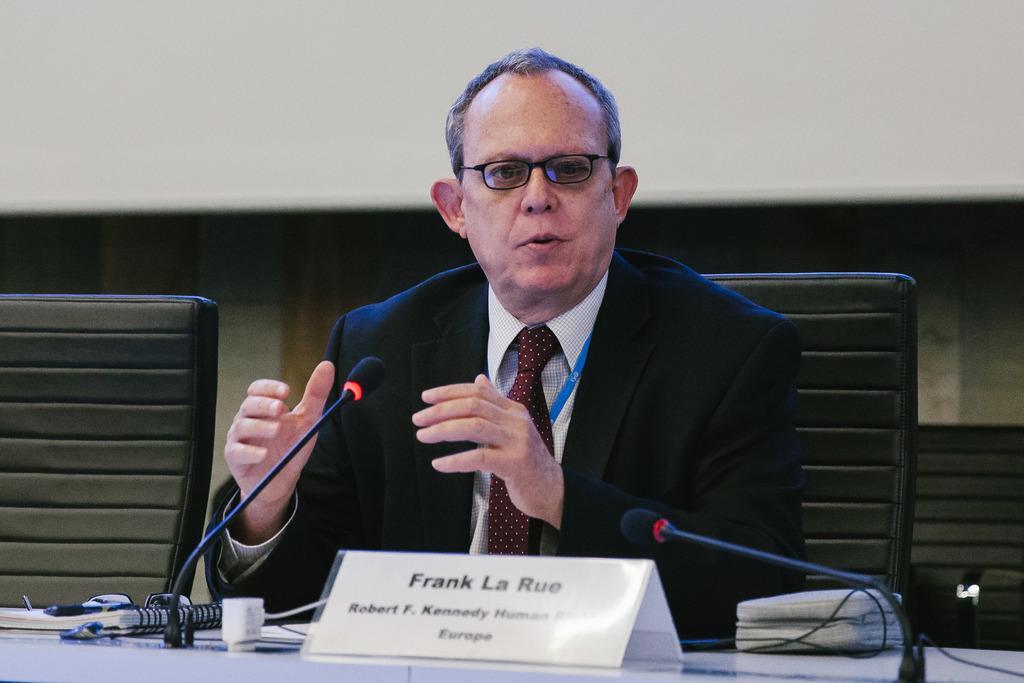Can you describe this image briefly? This is the man sitting on the chair and speaking. He wore a suit, shirt, tie and spectacles. This is the table with the miles, name board, book, adapter and few other things on it. This looks like an empty chair. 